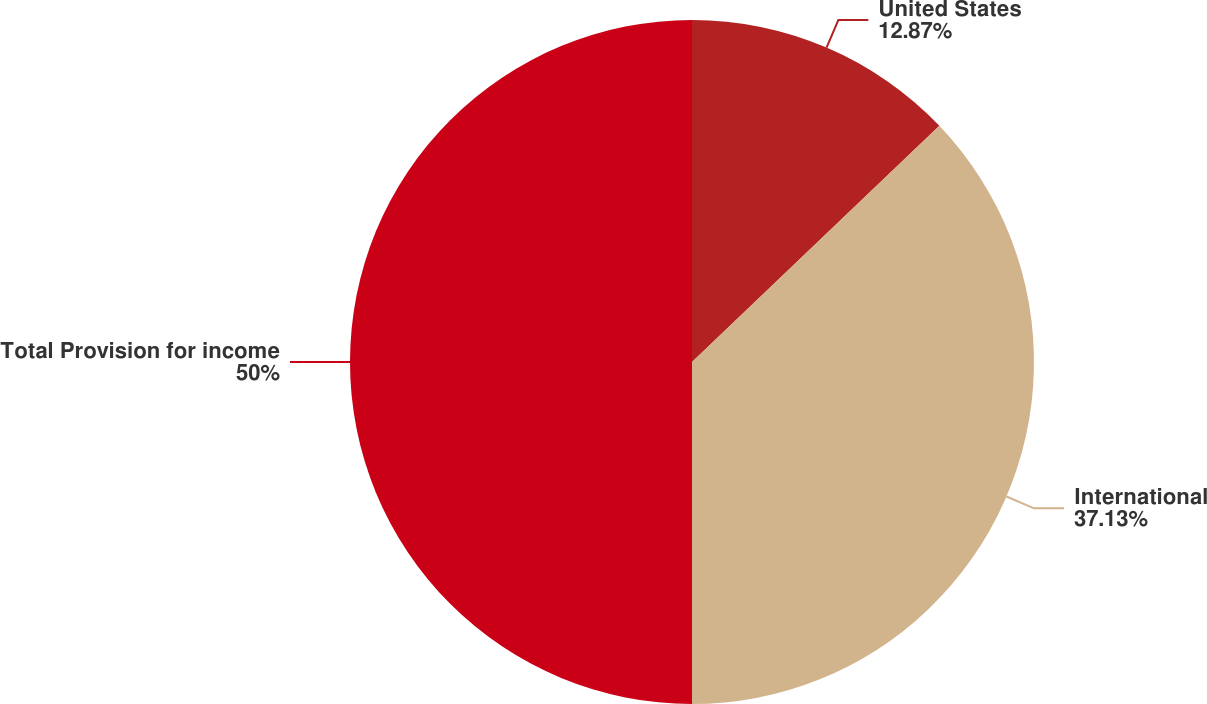<chart> <loc_0><loc_0><loc_500><loc_500><pie_chart><fcel>United States<fcel>International<fcel>Total Provision for income<nl><fcel>12.87%<fcel>37.13%<fcel>50.0%<nl></chart> 